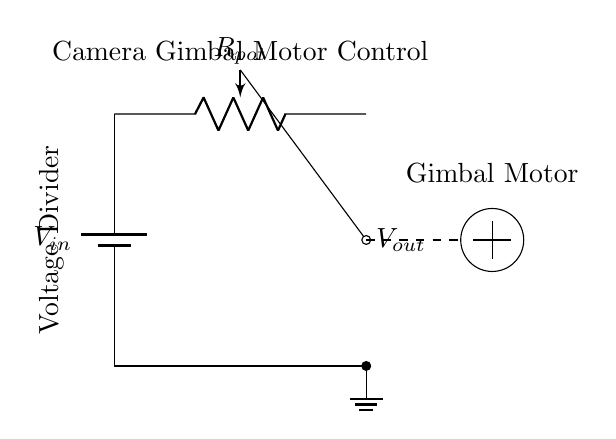What type of circuit is represented? The circuit is a voltage divider, which consists of resistive elements used to scale down voltage. The label in the diagram confirms this designation.
Answer: Voltage Divider What is the purpose of the potentiometer in this circuit? The potentiometer serves as a variable resistor, allowing for the adjustment of the output voltage. The wiper connects to the output, demonstrating its control functionality.
Answer: Control voltage What component is connected to the output of the voltage divider? The output connects to the gimbal motor, which is shown as a circular symbol in the diagram. The dashed line indicates the connection from the output to the motor.
Answer: Gimbal Motor What is the role of the battery in this circuit? The battery provides the input voltage needed for the circuit to function. The label indicates it as V_in, supplying power to the voltage divider.
Answer: Power supply How many terminals does the potentiometer have? The potentiometer typically has three terminals: two for the ends of the resistor and one for the wiper that adjusts output. The diagram indicates a standard connection.
Answer: Three What happens to the output voltage if the potentiometer is turned to the minimum setting? If the potentiometer is turned to the minimum setting, the output voltage (V_out) would approach zero volts, as it reduces the resistance path to the ground.
Answer: Approaching zero volts What is the relationship between the input voltage and output voltage in a voltage divider? The output voltage is a fraction of the input voltage based on the ratio of the resistances in the divider. This can be calculated using the voltage divider formula.
Answer: Fraction of input voltage 